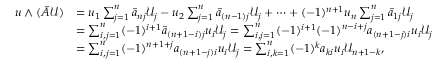<formula> <loc_0><loc_0><loc_500><loc_500>\begin{array} { r l } { u \wedge ( \tilde { A } \mathcal { U } ) } & { = u _ { 1 } \sum _ { j = 1 } ^ { n } \tilde { a } _ { n j } \mathcal { U } _ { j } - u _ { 2 } \sum _ { j = 1 } ^ { n } \tilde { a } _ { ( n - 1 ) j } \mathcal { U } _ { j } + \dots + ( - 1 ) ^ { n + 1 } u _ { n } \sum _ { j = 1 } ^ { n } \tilde { a } _ { 1 j } \mathcal { U } _ { j } } \\ & { = \sum _ { i , j = 1 } ^ { n } ( - 1 ) ^ { i + 1 } \tilde { a } _ { ( n + 1 - i ) j } u _ { i } \mathcal { U } _ { j } = \sum _ { i , j = 1 } ^ { n } ( - 1 ) ^ { i + 1 } ( - 1 ) ^ { n - i + j } a _ { ( n + 1 - j ) i } u _ { i } \mathcal { U } _ { j } } \\ & { = \sum _ { i , j = 1 } ^ { n } ( - 1 ) ^ { n + 1 + j } a _ { ( n + 1 - j ) i } u _ { i } \mathcal { U } _ { j } = \sum _ { i , k = 1 } ^ { n } ( - 1 ) ^ { k } a _ { k i } u _ { i } \mathcal { U } _ { n + 1 - k } , } \end{array}</formula> 